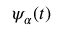<formula> <loc_0><loc_0><loc_500><loc_500>\psi _ { \alpha } ( t )</formula> 